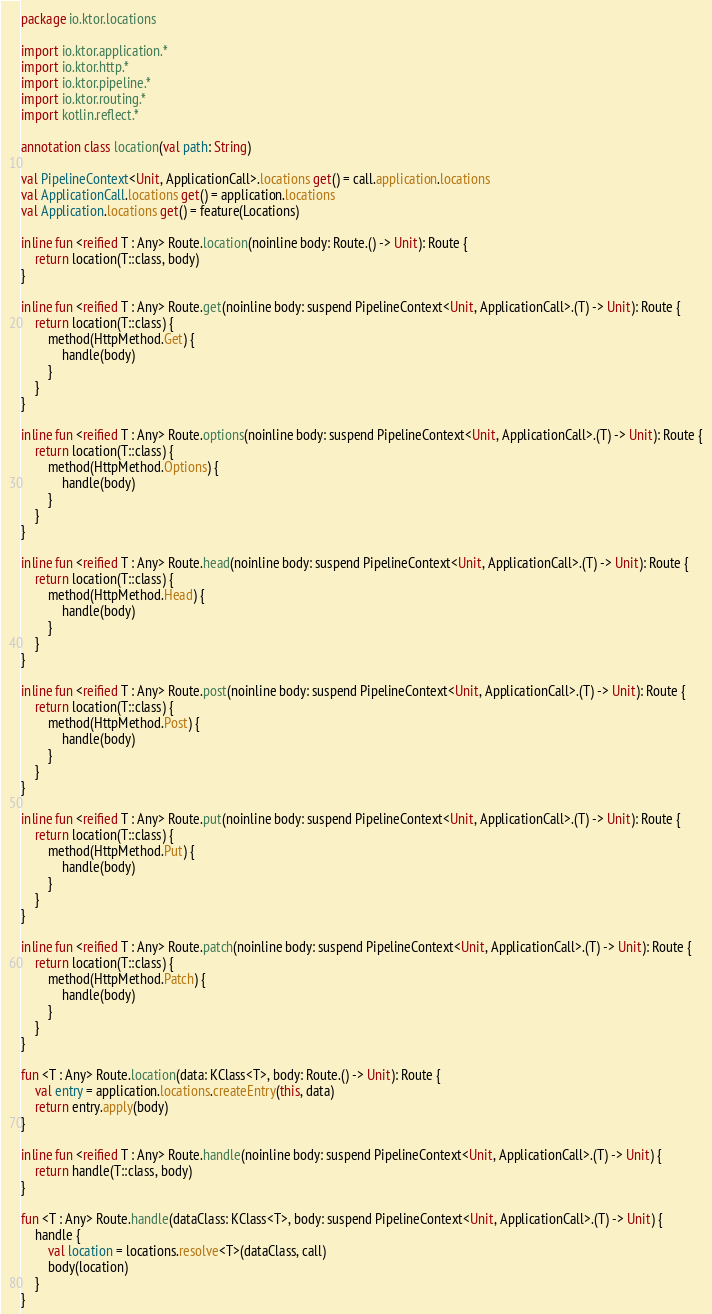Convert code to text. <code><loc_0><loc_0><loc_500><loc_500><_Kotlin_>package io.ktor.locations

import io.ktor.application.*
import io.ktor.http.*
import io.ktor.pipeline.*
import io.ktor.routing.*
import kotlin.reflect.*

annotation class location(val path: String)

val PipelineContext<Unit, ApplicationCall>.locations get() = call.application.locations
val ApplicationCall.locations get() = application.locations
val Application.locations get() = feature(Locations)

inline fun <reified T : Any> Route.location(noinline body: Route.() -> Unit): Route {
    return location(T::class, body)
}

inline fun <reified T : Any> Route.get(noinline body: suspend PipelineContext<Unit, ApplicationCall>.(T) -> Unit): Route {
    return location(T::class) {
        method(HttpMethod.Get) {
            handle(body)
        }
    }
}

inline fun <reified T : Any> Route.options(noinline body: suspend PipelineContext<Unit, ApplicationCall>.(T) -> Unit): Route {
    return location(T::class) {
        method(HttpMethod.Options) {
            handle(body)
        }
    }
}

inline fun <reified T : Any> Route.head(noinline body: suspend PipelineContext<Unit, ApplicationCall>.(T) -> Unit): Route {
    return location(T::class) {
        method(HttpMethod.Head) {
            handle(body)
        }
    }
}

inline fun <reified T : Any> Route.post(noinline body: suspend PipelineContext<Unit, ApplicationCall>.(T) -> Unit): Route {
    return location(T::class) {
        method(HttpMethod.Post) {
            handle(body)
        }
    }
}

inline fun <reified T : Any> Route.put(noinline body: suspend PipelineContext<Unit, ApplicationCall>.(T) -> Unit): Route {
    return location(T::class) {
        method(HttpMethod.Put) {
            handle(body)
        }
    }
}

inline fun <reified T : Any> Route.patch(noinline body: suspend PipelineContext<Unit, ApplicationCall>.(T) -> Unit): Route {
    return location(T::class) {
        method(HttpMethod.Patch) {
            handle(body)
        }
    }
}

fun <T : Any> Route.location(data: KClass<T>, body: Route.() -> Unit): Route {
    val entry = application.locations.createEntry(this, data)
    return entry.apply(body)
}

inline fun <reified T : Any> Route.handle(noinline body: suspend PipelineContext<Unit, ApplicationCall>.(T) -> Unit) {
    return handle(T::class, body)
}

fun <T : Any> Route.handle(dataClass: KClass<T>, body: suspend PipelineContext<Unit, ApplicationCall>.(T) -> Unit) {
    handle {
        val location = locations.resolve<T>(dataClass, call)
        body(location)
    }
}
</code> 